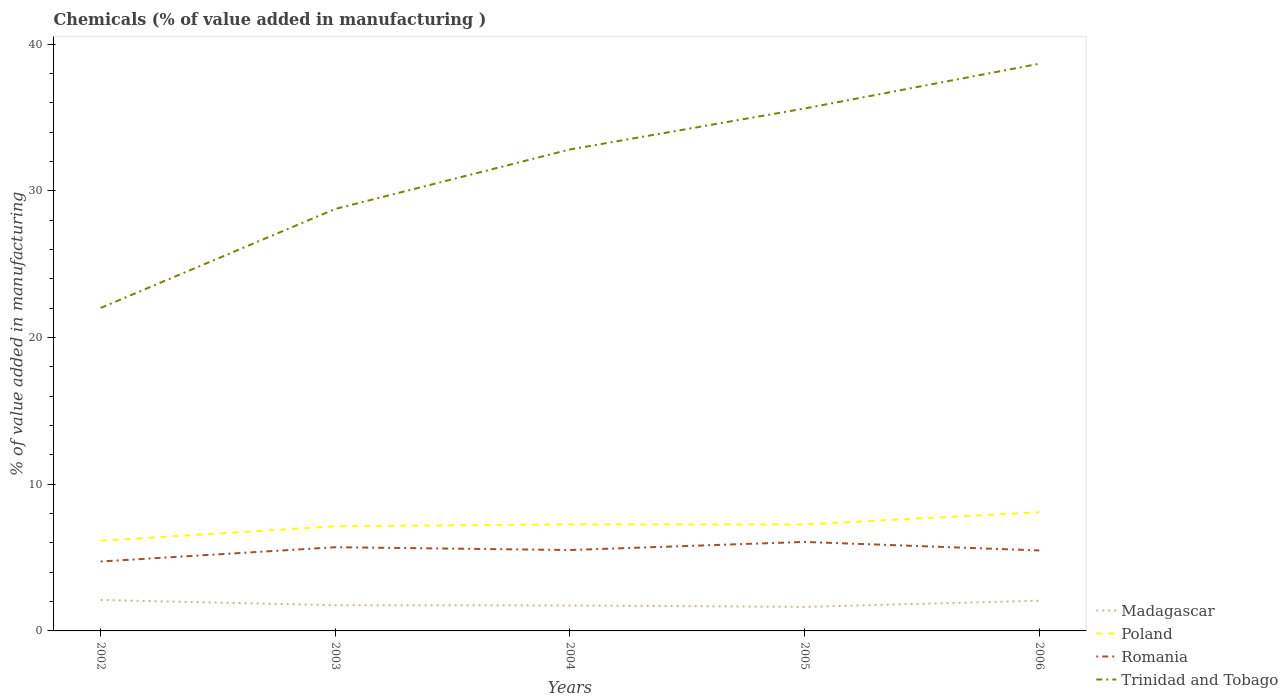How many different coloured lines are there?
Make the answer very short. 4. Does the line corresponding to Trinidad and Tobago intersect with the line corresponding to Poland?
Offer a terse response. No. Is the number of lines equal to the number of legend labels?
Make the answer very short. Yes. Across all years, what is the maximum value added in manufacturing chemicals in Madagascar?
Give a very brief answer. 1.64. What is the total value added in manufacturing chemicals in Trinidad and Tobago in the graph?
Provide a short and direct response. -13.6. What is the difference between the highest and the second highest value added in manufacturing chemicals in Romania?
Provide a short and direct response. 1.33. What is the difference between the highest and the lowest value added in manufacturing chemicals in Madagascar?
Make the answer very short. 2. How many years are there in the graph?
Offer a very short reply. 5. What is the difference between two consecutive major ticks on the Y-axis?
Keep it short and to the point. 10. Are the values on the major ticks of Y-axis written in scientific E-notation?
Provide a short and direct response. No. Does the graph contain grids?
Your answer should be compact. No. Where does the legend appear in the graph?
Your answer should be compact. Bottom right. How many legend labels are there?
Your response must be concise. 4. What is the title of the graph?
Ensure brevity in your answer.  Chemicals (% of value added in manufacturing ). Does "Armenia" appear as one of the legend labels in the graph?
Provide a short and direct response. No. What is the label or title of the Y-axis?
Provide a succinct answer. % of value added in manufacturing. What is the % of value added in manufacturing in Madagascar in 2002?
Your response must be concise. 2.11. What is the % of value added in manufacturing of Poland in 2002?
Offer a terse response. 6.15. What is the % of value added in manufacturing of Romania in 2002?
Give a very brief answer. 4.73. What is the % of value added in manufacturing in Trinidad and Tobago in 2002?
Provide a short and direct response. 22.02. What is the % of value added in manufacturing of Madagascar in 2003?
Offer a very short reply. 1.75. What is the % of value added in manufacturing in Poland in 2003?
Keep it short and to the point. 7.13. What is the % of value added in manufacturing in Romania in 2003?
Make the answer very short. 5.71. What is the % of value added in manufacturing of Trinidad and Tobago in 2003?
Offer a very short reply. 28.77. What is the % of value added in manufacturing in Madagascar in 2004?
Provide a short and direct response. 1.74. What is the % of value added in manufacturing of Poland in 2004?
Offer a very short reply. 7.26. What is the % of value added in manufacturing of Romania in 2004?
Provide a succinct answer. 5.51. What is the % of value added in manufacturing of Trinidad and Tobago in 2004?
Make the answer very short. 32.82. What is the % of value added in manufacturing in Madagascar in 2005?
Offer a very short reply. 1.64. What is the % of value added in manufacturing of Poland in 2005?
Provide a short and direct response. 7.26. What is the % of value added in manufacturing in Romania in 2005?
Your answer should be very brief. 6.07. What is the % of value added in manufacturing in Trinidad and Tobago in 2005?
Make the answer very short. 35.61. What is the % of value added in manufacturing in Madagascar in 2006?
Your answer should be compact. 2.06. What is the % of value added in manufacturing of Poland in 2006?
Your answer should be compact. 8.09. What is the % of value added in manufacturing of Romania in 2006?
Offer a terse response. 5.49. What is the % of value added in manufacturing of Trinidad and Tobago in 2006?
Provide a succinct answer. 38.67. Across all years, what is the maximum % of value added in manufacturing in Madagascar?
Provide a succinct answer. 2.11. Across all years, what is the maximum % of value added in manufacturing in Poland?
Provide a short and direct response. 8.09. Across all years, what is the maximum % of value added in manufacturing in Romania?
Make the answer very short. 6.07. Across all years, what is the maximum % of value added in manufacturing of Trinidad and Tobago?
Your response must be concise. 38.67. Across all years, what is the minimum % of value added in manufacturing in Madagascar?
Give a very brief answer. 1.64. Across all years, what is the minimum % of value added in manufacturing of Poland?
Your response must be concise. 6.15. Across all years, what is the minimum % of value added in manufacturing in Romania?
Your answer should be compact. 4.73. Across all years, what is the minimum % of value added in manufacturing of Trinidad and Tobago?
Give a very brief answer. 22.02. What is the total % of value added in manufacturing of Madagascar in the graph?
Provide a succinct answer. 9.3. What is the total % of value added in manufacturing of Poland in the graph?
Ensure brevity in your answer.  35.9. What is the total % of value added in manufacturing of Romania in the graph?
Your answer should be very brief. 27.51. What is the total % of value added in manufacturing in Trinidad and Tobago in the graph?
Your answer should be compact. 157.89. What is the difference between the % of value added in manufacturing in Madagascar in 2002 and that in 2003?
Your response must be concise. 0.36. What is the difference between the % of value added in manufacturing of Poland in 2002 and that in 2003?
Offer a terse response. -0.99. What is the difference between the % of value added in manufacturing of Romania in 2002 and that in 2003?
Provide a succinct answer. -0.97. What is the difference between the % of value added in manufacturing of Trinidad and Tobago in 2002 and that in 2003?
Your answer should be very brief. -6.75. What is the difference between the % of value added in manufacturing of Madagascar in 2002 and that in 2004?
Your response must be concise. 0.37. What is the difference between the % of value added in manufacturing in Poland in 2002 and that in 2004?
Your answer should be very brief. -1.12. What is the difference between the % of value added in manufacturing of Romania in 2002 and that in 2004?
Your answer should be compact. -0.78. What is the difference between the % of value added in manufacturing of Trinidad and Tobago in 2002 and that in 2004?
Provide a succinct answer. -10.8. What is the difference between the % of value added in manufacturing in Madagascar in 2002 and that in 2005?
Make the answer very short. 0.47. What is the difference between the % of value added in manufacturing of Poland in 2002 and that in 2005?
Provide a short and direct response. -1.12. What is the difference between the % of value added in manufacturing in Romania in 2002 and that in 2005?
Provide a short and direct response. -1.33. What is the difference between the % of value added in manufacturing in Trinidad and Tobago in 2002 and that in 2005?
Offer a very short reply. -13.6. What is the difference between the % of value added in manufacturing of Madagascar in 2002 and that in 2006?
Provide a short and direct response. 0.05. What is the difference between the % of value added in manufacturing of Poland in 2002 and that in 2006?
Your response must be concise. -1.94. What is the difference between the % of value added in manufacturing in Romania in 2002 and that in 2006?
Your answer should be compact. -0.75. What is the difference between the % of value added in manufacturing of Trinidad and Tobago in 2002 and that in 2006?
Your answer should be compact. -16.65. What is the difference between the % of value added in manufacturing of Madagascar in 2003 and that in 2004?
Keep it short and to the point. 0.01. What is the difference between the % of value added in manufacturing in Poland in 2003 and that in 2004?
Give a very brief answer. -0.13. What is the difference between the % of value added in manufacturing of Romania in 2003 and that in 2004?
Your response must be concise. 0.19. What is the difference between the % of value added in manufacturing of Trinidad and Tobago in 2003 and that in 2004?
Keep it short and to the point. -4.05. What is the difference between the % of value added in manufacturing of Madagascar in 2003 and that in 2005?
Your answer should be very brief. 0.11. What is the difference between the % of value added in manufacturing of Poland in 2003 and that in 2005?
Your response must be concise. -0.13. What is the difference between the % of value added in manufacturing of Romania in 2003 and that in 2005?
Make the answer very short. -0.36. What is the difference between the % of value added in manufacturing of Trinidad and Tobago in 2003 and that in 2005?
Offer a very short reply. -6.85. What is the difference between the % of value added in manufacturing of Madagascar in 2003 and that in 2006?
Your answer should be very brief. -0.31. What is the difference between the % of value added in manufacturing of Poland in 2003 and that in 2006?
Provide a short and direct response. -0.96. What is the difference between the % of value added in manufacturing in Romania in 2003 and that in 2006?
Offer a terse response. 0.22. What is the difference between the % of value added in manufacturing in Trinidad and Tobago in 2003 and that in 2006?
Your response must be concise. -9.9. What is the difference between the % of value added in manufacturing in Madagascar in 2004 and that in 2005?
Your answer should be compact. 0.1. What is the difference between the % of value added in manufacturing in Poland in 2004 and that in 2005?
Offer a terse response. 0. What is the difference between the % of value added in manufacturing in Romania in 2004 and that in 2005?
Provide a succinct answer. -0.55. What is the difference between the % of value added in manufacturing in Trinidad and Tobago in 2004 and that in 2005?
Provide a short and direct response. -2.79. What is the difference between the % of value added in manufacturing of Madagascar in 2004 and that in 2006?
Your response must be concise. -0.32. What is the difference between the % of value added in manufacturing of Poland in 2004 and that in 2006?
Ensure brevity in your answer.  -0.83. What is the difference between the % of value added in manufacturing of Romania in 2004 and that in 2006?
Your answer should be very brief. 0.03. What is the difference between the % of value added in manufacturing of Trinidad and Tobago in 2004 and that in 2006?
Offer a terse response. -5.84. What is the difference between the % of value added in manufacturing of Madagascar in 2005 and that in 2006?
Provide a succinct answer. -0.42. What is the difference between the % of value added in manufacturing in Poland in 2005 and that in 2006?
Ensure brevity in your answer.  -0.83. What is the difference between the % of value added in manufacturing of Romania in 2005 and that in 2006?
Your answer should be very brief. 0.58. What is the difference between the % of value added in manufacturing in Trinidad and Tobago in 2005 and that in 2006?
Your response must be concise. -3.05. What is the difference between the % of value added in manufacturing in Madagascar in 2002 and the % of value added in manufacturing in Poland in 2003?
Ensure brevity in your answer.  -5.03. What is the difference between the % of value added in manufacturing of Madagascar in 2002 and the % of value added in manufacturing of Romania in 2003?
Your answer should be very brief. -3.6. What is the difference between the % of value added in manufacturing of Madagascar in 2002 and the % of value added in manufacturing of Trinidad and Tobago in 2003?
Keep it short and to the point. -26.66. What is the difference between the % of value added in manufacturing in Poland in 2002 and the % of value added in manufacturing in Romania in 2003?
Provide a short and direct response. 0.44. What is the difference between the % of value added in manufacturing in Poland in 2002 and the % of value added in manufacturing in Trinidad and Tobago in 2003?
Keep it short and to the point. -22.62. What is the difference between the % of value added in manufacturing in Romania in 2002 and the % of value added in manufacturing in Trinidad and Tobago in 2003?
Your answer should be very brief. -24.03. What is the difference between the % of value added in manufacturing of Madagascar in 2002 and the % of value added in manufacturing of Poland in 2004?
Your answer should be compact. -5.16. What is the difference between the % of value added in manufacturing in Madagascar in 2002 and the % of value added in manufacturing in Romania in 2004?
Your answer should be compact. -3.41. What is the difference between the % of value added in manufacturing of Madagascar in 2002 and the % of value added in manufacturing of Trinidad and Tobago in 2004?
Ensure brevity in your answer.  -30.71. What is the difference between the % of value added in manufacturing in Poland in 2002 and the % of value added in manufacturing in Romania in 2004?
Keep it short and to the point. 0.63. What is the difference between the % of value added in manufacturing of Poland in 2002 and the % of value added in manufacturing of Trinidad and Tobago in 2004?
Keep it short and to the point. -26.68. What is the difference between the % of value added in manufacturing of Romania in 2002 and the % of value added in manufacturing of Trinidad and Tobago in 2004?
Your response must be concise. -28.09. What is the difference between the % of value added in manufacturing in Madagascar in 2002 and the % of value added in manufacturing in Poland in 2005?
Keep it short and to the point. -5.15. What is the difference between the % of value added in manufacturing of Madagascar in 2002 and the % of value added in manufacturing of Romania in 2005?
Offer a terse response. -3.96. What is the difference between the % of value added in manufacturing of Madagascar in 2002 and the % of value added in manufacturing of Trinidad and Tobago in 2005?
Your response must be concise. -33.51. What is the difference between the % of value added in manufacturing of Poland in 2002 and the % of value added in manufacturing of Romania in 2005?
Provide a succinct answer. 0.08. What is the difference between the % of value added in manufacturing of Poland in 2002 and the % of value added in manufacturing of Trinidad and Tobago in 2005?
Offer a very short reply. -29.47. What is the difference between the % of value added in manufacturing of Romania in 2002 and the % of value added in manufacturing of Trinidad and Tobago in 2005?
Keep it short and to the point. -30.88. What is the difference between the % of value added in manufacturing in Madagascar in 2002 and the % of value added in manufacturing in Poland in 2006?
Offer a terse response. -5.98. What is the difference between the % of value added in manufacturing of Madagascar in 2002 and the % of value added in manufacturing of Romania in 2006?
Ensure brevity in your answer.  -3.38. What is the difference between the % of value added in manufacturing of Madagascar in 2002 and the % of value added in manufacturing of Trinidad and Tobago in 2006?
Provide a succinct answer. -36.56. What is the difference between the % of value added in manufacturing of Poland in 2002 and the % of value added in manufacturing of Romania in 2006?
Ensure brevity in your answer.  0.66. What is the difference between the % of value added in manufacturing of Poland in 2002 and the % of value added in manufacturing of Trinidad and Tobago in 2006?
Give a very brief answer. -32.52. What is the difference between the % of value added in manufacturing in Romania in 2002 and the % of value added in manufacturing in Trinidad and Tobago in 2006?
Your answer should be very brief. -33.93. What is the difference between the % of value added in manufacturing in Madagascar in 2003 and the % of value added in manufacturing in Poland in 2004?
Provide a succinct answer. -5.51. What is the difference between the % of value added in manufacturing in Madagascar in 2003 and the % of value added in manufacturing in Romania in 2004?
Ensure brevity in your answer.  -3.76. What is the difference between the % of value added in manufacturing in Madagascar in 2003 and the % of value added in manufacturing in Trinidad and Tobago in 2004?
Your response must be concise. -31.07. What is the difference between the % of value added in manufacturing of Poland in 2003 and the % of value added in manufacturing of Romania in 2004?
Make the answer very short. 1.62. What is the difference between the % of value added in manufacturing in Poland in 2003 and the % of value added in manufacturing in Trinidad and Tobago in 2004?
Keep it short and to the point. -25.69. What is the difference between the % of value added in manufacturing in Romania in 2003 and the % of value added in manufacturing in Trinidad and Tobago in 2004?
Your response must be concise. -27.11. What is the difference between the % of value added in manufacturing of Madagascar in 2003 and the % of value added in manufacturing of Poland in 2005?
Offer a very short reply. -5.51. What is the difference between the % of value added in manufacturing of Madagascar in 2003 and the % of value added in manufacturing of Romania in 2005?
Provide a succinct answer. -4.32. What is the difference between the % of value added in manufacturing in Madagascar in 2003 and the % of value added in manufacturing in Trinidad and Tobago in 2005?
Give a very brief answer. -33.86. What is the difference between the % of value added in manufacturing of Poland in 2003 and the % of value added in manufacturing of Romania in 2005?
Your answer should be compact. 1.07. What is the difference between the % of value added in manufacturing of Poland in 2003 and the % of value added in manufacturing of Trinidad and Tobago in 2005?
Ensure brevity in your answer.  -28.48. What is the difference between the % of value added in manufacturing of Romania in 2003 and the % of value added in manufacturing of Trinidad and Tobago in 2005?
Give a very brief answer. -29.91. What is the difference between the % of value added in manufacturing in Madagascar in 2003 and the % of value added in manufacturing in Poland in 2006?
Provide a short and direct response. -6.34. What is the difference between the % of value added in manufacturing in Madagascar in 2003 and the % of value added in manufacturing in Romania in 2006?
Provide a short and direct response. -3.73. What is the difference between the % of value added in manufacturing of Madagascar in 2003 and the % of value added in manufacturing of Trinidad and Tobago in 2006?
Offer a terse response. -36.91. What is the difference between the % of value added in manufacturing of Poland in 2003 and the % of value added in manufacturing of Romania in 2006?
Give a very brief answer. 1.65. What is the difference between the % of value added in manufacturing in Poland in 2003 and the % of value added in manufacturing in Trinidad and Tobago in 2006?
Give a very brief answer. -31.53. What is the difference between the % of value added in manufacturing of Romania in 2003 and the % of value added in manufacturing of Trinidad and Tobago in 2006?
Your answer should be compact. -32.96. What is the difference between the % of value added in manufacturing of Madagascar in 2004 and the % of value added in manufacturing of Poland in 2005?
Offer a terse response. -5.52. What is the difference between the % of value added in manufacturing in Madagascar in 2004 and the % of value added in manufacturing in Romania in 2005?
Ensure brevity in your answer.  -4.33. What is the difference between the % of value added in manufacturing of Madagascar in 2004 and the % of value added in manufacturing of Trinidad and Tobago in 2005?
Provide a succinct answer. -33.88. What is the difference between the % of value added in manufacturing of Poland in 2004 and the % of value added in manufacturing of Romania in 2005?
Your answer should be very brief. 1.2. What is the difference between the % of value added in manufacturing in Poland in 2004 and the % of value added in manufacturing in Trinidad and Tobago in 2005?
Your response must be concise. -28.35. What is the difference between the % of value added in manufacturing of Romania in 2004 and the % of value added in manufacturing of Trinidad and Tobago in 2005?
Ensure brevity in your answer.  -30.1. What is the difference between the % of value added in manufacturing in Madagascar in 2004 and the % of value added in manufacturing in Poland in 2006?
Make the answer very short. -6.35. What is the difference between the % of value added in manufacturing of Madagascar in 2004 and the % of value added in manufacturing of Romania in 2006?
Offer a terse response. -3.75. What is the difference between the % of value added in manufacturing of Madagascar in 2004 and the % of value added in manufacturing of Trinidad and Tobago in 2006?
Your answer should be very brief. -36.93. What is the difference between the % of value added in manufacturing of Poland in 2004 and the % of value added in manufacturing of Romania in 2006?
Keep it short and to the point. 1.78. What is the difference between the % of value added in manufacturing of Poland in 2004 and the % of value added in manufacturing of Trinidad and Tobago in 2006?
Make the answer very short. -31.4. What is the difference between the % of value added in manufacturing in Romania in 2004 and the % of value added in manufacturing in Trinidad and Tobago in 2006?
Offer a terse response. -33.15. What is the difference between the % of value added in manufacturing in Madagascar in 2005 and the % of value added in manufacturing in Poland in 2006?
Make the answer very short. -6.45. What is the difference between the % of value added in manufacturing in Madagascar in 2005 and the % of value added in manufacturing in Romania in 2006?
Keep it short and to the point. -3.85. What is the difference between the % of value added in manufacturing of Madagascar in 2005 and the % of value added in manufacturing of Trinidad and Tobago in 2006?
Provide a succinct answer. -37.03. What is the difference between the % of value added in manufacturing in Poland in 2005 and the % of value added in manufacturing in Romania in 2006?
Offer a terse response. 1.78. What is the difference between the % of value added in manufacturing of Poland in 2005 and the % of value added in manufacturing of Trinidad and Tobago in 2006?
Offer a very short reply. -31.4. What is the difference between the % of value added in manufacturing of Romania in 2005 and the % of value added in manufacturing of Trinidad and Tobago in 2006?
Provide a short and direct response. -32.6. What is the average % of value added in manufacturing of Madagascar per year?
Make the answer very short. 1.86. What is the average % of value added in manufacturing of Poland per year?
Offer a terse response. 7.18. What is the average % of value added in manufacturing in Romania per year?
Make the answer very short. 5.5. What is the average % of value added in manufacturing in Trinidad and Tobago per year?
Provide a succinct answer. 31.58. In the year 2002, what is the difference between the % of value added in manufacturing of Madagascar and % of value added in manufacturing of Poland?
Your answer should be compact. -4.04. In the year 2002, what is the difference between the % of value added in manufacturing in Madagascar and % of value added in manufacturing in Romania?
Ensure brevity in your answer.  -2.62. In the year 2002, what is the difference between the % of value added in manufacturing of Madagascar and % of value added in manufacturing of Trinidad and Tobago?
Make the answer very short. -19.91. In the year 2002, what is the difference between the % of value added in manufacturing of Poland and % of value added in manufacturing of Romania?
Make the answer very short. 1.41. In the year 2002, what is the difference between the % of value added in manufacturing in Poland and % of value added in manufacturing in Trinidad and Tobago?
Your response must be concise. -15.87. In the year 2002, what is the difference between the % of value added in manufacturing of Romania and % of value added in manufacturing of Trinidad and Tobago?
Your response must be concise. -17.28. In the year 2003, what is the difference between the % of value added in manufacturing in Madagascar and % of value added in manufacturing in Poland?
Keep it short and to the point. -5.38. In the year 2003, what is the difference between the % of value added in manufacturing in Madagascar and % of value added in manufacturing in Romania?
Your answer should be very brief. -3.95. In the year 2003, what is the difference between the % of value added in manufacturing of Madagascar and % of value added in manufacturing of Trinidad and Tobago?
Your answer should be very brief. -27.02. In the year 2003, what is the difference between the % of value added in manufacturing in Poland and % of value added in manufacturing in Romania?
Offer a very short reply. 1.43. In the year 2003, what is the difference between the % of value added in manufacturing of Poland and % of value added in manufacturing of Trinidad and Tobago?
Offer a terse response. -21.63. In the year 2003, what is the difference between the % of value added in manufacturing of Romania and % of value added in manufacturing of Trinidad and Tobago?
Ensure brevity in your answer.  -23.06. In the year 2004, what is the difference between the % of value added in manufacturing of Madagascar and % of value added in manufacturing of Poland?
Offer a very short reply. -5.53. In the year 2004, what is the difference between the % of value added in manufacturing in Madagascar and % of value added in manufacturing in Romania?
Your answer should be very brief. -3.78. In the year 2004, what is the difference between the % of value added in manufacturing in Madagascar and % of value added in manufacturing in Trinidad and Tobago?
Offer a very short reply. -31.08. In the year 2004, what is the difference between the % of value added in manufacturing of Poland and % of value added in manufacturing of Romania?
Provide a short and direct response. 1.75. In the year 2004, what is the difference between the % of value added in manufacturing in Poland and % of value added in manufacturing in Trinidad and Tobago?
Offer a terse response. -25.56. In the year 2004, what is the difference between the % of value added in manufacturing of Romania and % of value added in manufacturing of Trinidad and Tobago?
Keep it short and to the point. -27.31. In the year 2005, what is the difference between the % of value added in manufacturing in Madagascar and % of value added in manufacturing in Poland?
Your answer should be very brief. -5.62. In the year 2005, what is the difference between the % of value added in manufacturing in Madagascar and % of value added in manufacturing in Romania?
Give a very brief answer. -4.43. In the year 2005, what is the difference between the % of value added in manufacturing of Madagascar and % of value added in manufacturing of Trinidad and Tobago?
Give a very brief answer. -33.98. In the year 2005, what is the difference between the % of value added in manufacturing of Poland and % of value added in manufacturing of Romania?
Provide a short and direct response. 1.19. In the year 2005, what is the difference between the % of value added in manufacturing in Poland and % of value added in manufacturing in Trinidad and Tobago?
Make the answer very short. -28.35. In the year 2005, what is the difference between the % of value added in manufacturing of Romania and % of value added in manufacturing of Trinidad and Tobago?
Your answer should be compact. -29.55. In the year 2006, what is the difference between the % of value added in manufacturing of Madagascar and % of value added in manufacturing of Poland?
Make the answer very short. -6.03. In the year 2006, what is the difference between the % of value added in manufacturing in Madagascar and % of value added in manufacturing in Romania?
Your answer should be compact. -3.43. In the year 2006, what is the difference between the % of value added in manufacturing in Madagascar and % of value added in manufacturing in Trinidad and Tobago?
Offer a very short reply. -36.61. In the year 2006, what is the difference between the % of value added in manufacturing of Poland and % of value added in manufacturing of Romania?
Ensure brevity in your answer.  2.61. In the year 2006, what is the difference between the % of value added in manufacturing in Poland and % of value added in manufacturing in Trinidad and Tobago?
Keep it short and to the point. -30.57. In the year 2006, what is the difference between the % of value added in manufacturing in Romania and % of value added in manufacturing in Trinidad and Tobago?
Your response must be concise. -33.18. What is the ratio of the % of value added in manufacturing in Madagascar in 2002 to that in 2003?
Ensure brevity in your answer.  1.2. What is the ratio of the % of value added in manufacturing of Poland in 2002 to that in 2003?
Provide a short and direct response. 0.86. What is the ratio of the % of value added in manufacturing of Romania in 2002 to that in 2003?
Make the answer very short. 0.83. What is the ratio of the % of value added in manufacturing in Trinidad and Tobago in 2002 to that in 2003?
Your answer should be compact. 0.77. What is the ratio of the % of value added in manufacturing of Madagascar in 2002 to that in 2004?
Keep it short and to the point. 1.21. What is the ratio of the % of value added in manufacturing in Poland in 2002 to that in 2004?
Keep it short and to the point. 0.85. What is the ratio of the % of value added in manufacturing in Romania in 2002 to that in 2004?
Keep it short and to the point. 0.86. What is the ratio of the % of value added in manufacturing of Trinidad and Tobago in 2002 to that in 2004?
Offer a terse response. 0.67. What is the ratio of the % of value added in manufacturing in Madagascar in 2002 to that in 2005?
Offer a terse response. 1.29. What is the ratio of the % of value added in manufacturing in Poland in 2002 to that in 2005?
Provide a short and direct response. 0.85. What is the ratio of the % of value added in manufacturing in Romania in 2002 to that in 2005?
Your answer should be very brief. 0.78. What is the ratio of the % of value added in manufacturing of Trinidad and Tobago in 2002 to that in 2005?
Give a very brief answer. 0.62. What is the ratio of the % of value added in manufacturing in Madagascar in 2002 to that in 2006?
Provide a succinct answer. 1.02. What is the ratio of the % of value added in manufacturing of Poland in 2002 to that in 2006?
Your answer should be compact. 0.76. What is the ratio of the % of value added in manufacturing in Romania in 2002 to that in 2006?
Make the answer very short. 0.86. What is the ratio of the % of value added in manufacturing in Trinidad and Tobago in 2002 to that in 2006?
Keep it short and to the point. 0.57. What is the ratio of the % of value added in manufacturing in Madagascar in 2003 to that in 2004?
Keep it short and to the point. 1.01. What is the ratio of the % of value added in manufacturing of Poland in 2003 to that in 2004?
Your answer should be very brief. 0.98. What is the ratio of the % of value added in manufacturing of Romania in 2003 to that in 2004?
Ensure brevity in your answer.  1.03. What is the ratio of the % of value added in manufacturing in Trinidad and Tobago in 2003 to that in 2004?
Ensure brevity in your answer.  0.88. What is the ratio of the % of value added in manufacturing in Madagascar in 2003 to that in 2005?
Offer a terse response. 1.07. What is the ratio of the % of value added in manufacturing of Poland in 2003 to that in 2005?
Offer a terse response. 0.98. What is the ratio of the % of value added in manufacturing of Romania in 2003 to that in 2005?
Give a very brief answer. 0.94. What is the ratio of the % of value added in manufacturing of Trinidad and Tobago in 2003 to that in 2005?
Ensure brevity in your answer.  0.81. What is the ratio of the % of value added in manufacturing of Madagascar in 2003 to that in 2006?
Your answer should be compact. 0.85. What is the ratio of the % of value added in manufacturing of Poland in 2003 to that in 2006?
Make the answer very short. 0.88. What is the ratio of the % of value added in manufacturing of Romania in 2003 to that in 2006?
Keep it short and to the point. 1.04. What is the ratio of the % of value added in manufacturing in Trinidad and Tobago in 2003 to that in 2006?
Offer a terse response. 0.74. What is the ratio of the % of value added in manufacturing in Madagascar in 2004 to that in 2005?
Provide a short and direct response. 1.06. What is the ratio of the % of value added in manufacturing of Poland in 2004 to that in 2005?
Give a very brief answer. 1. What is the ratio of the % of value added in manufacturing in Romania in 2004 to that in 2005?
Your answer should be very brief. 0.91. What is the ratio of the % of value added in manufacturing of Trinidad and Tobago in 2004 to that in 2005?
Your response must be concise. 0.92. What is the ratio of the % of value added in manufacturing of Madagascar in 2004 to that in 2006?
Offer a very short reply. 0.84. What is the ratio of the % of value added in manufacturing in Poland in 2004 to that in 2006?
Your response must be concise. 0.9. What is the ratio of the % of value added in manufacturing of Trinidad and Tobago in 2004 to that in 2006?
Your answer should be very brief. 0.85. What is the ratio of the % of value added in manufacturing of Madagascar in 2005 to that in 2006?
Offer a terse response. 0.8. What is the ratio of the % of value added in manufacturing of Poland in 2005 to that in 2006?
Offer a very short reply. 0.9. What is the ratio of the % of value added in manufacturing in Romania in 2005 to that in 2006?
Provide a short and direct response. 1.11. What is the ratio of the % of value added in manufacturing of Trinidad and Tobago in 2005 to that in 2006?
Your answer should be compact. 0.92. What is the difference between the highest and the second highest % of value added in manufacturing of Madagascar?
Ensure brevity in your answer.  0.05. What is the difference between the highest and the second highest % of value added in manufacturing of Poland?
Make the answer very short. 0.83. What is the difference between the highest and the second highest % of value added in manufacturing in Romania?
Provide a short and direct response. 0.36. What is the difference between the highest and the second highest % of value added in manufacturing of Trinidad and Tobago?
Provide a short and direct response. 3.05. What is the difference between the highest and the lowest % of value added in manufacturing of Madagascar?
Offer a very short reply. 0.47. What is the difference between the highest and the lowest % of value added in manufacturing of Poland?
Offer a very short reply. 1.94. What is the difference between the highest and the lowest % of value added in manufacturing of Romania?
Offer a terse response. 1.33. What is the difference between the highest and the lowest % of value added in manufacturing in Trinidad and Tobago?
Provide a short and direct response. 16.65. 